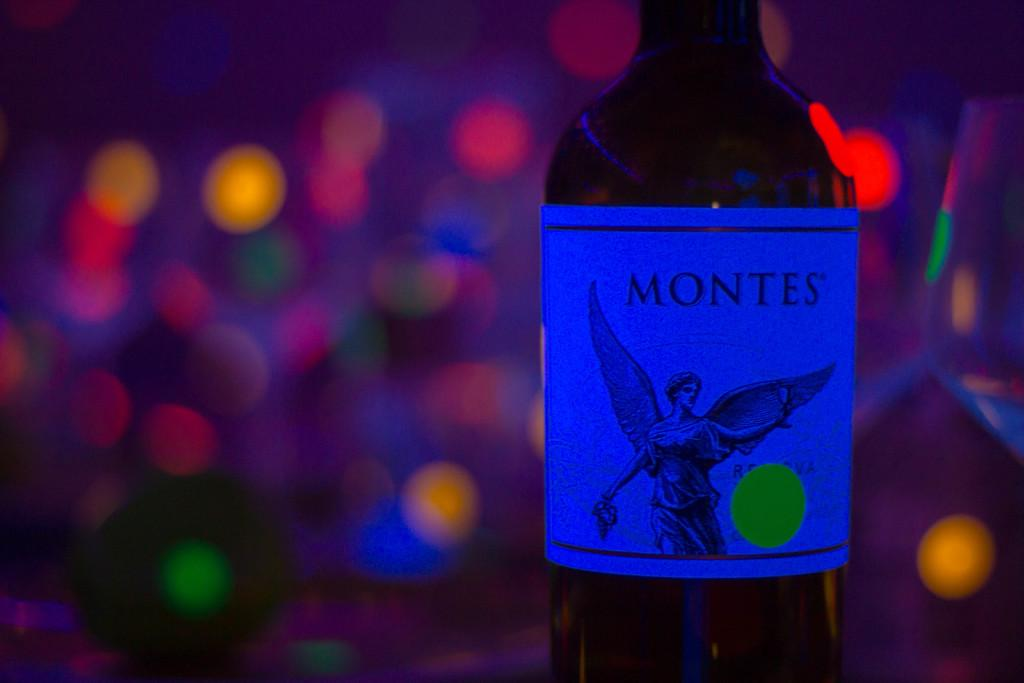Provide a one-sentence caption for the provided image. A Montes  bottle of wine with an angel on the label and lights in the background. 